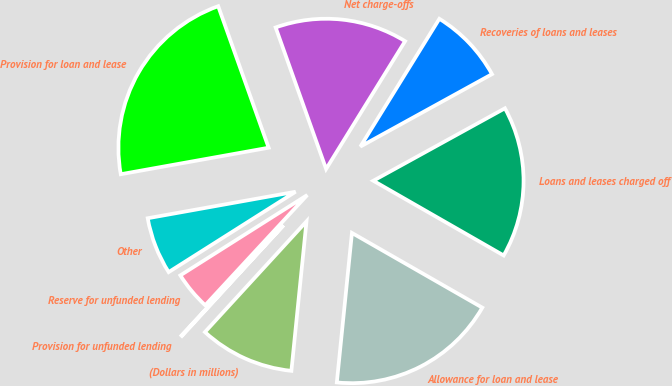<chart> <loc_0><loc_0><loc_500><loc_500><pie_chart><fcel>(Dollars in millions)<fcel>Allowance for loan and lease<fcel>Loans and leases charged off<fcel>Recoveries of loans and leases<fcel>Net charge-offs<fcel>Provision for loan and lease<fcel>Other<fcel>Reserve for unfunded lending<fcel>Provision for unfunded lending<nl><fcel>10.21%<fcel>18.32%<fcel>16.29%<fcel>8.18%<fcel>14.26%<fcel>22.37%<fcel>6.16%<fcel>4.13%<fcel>0.07%<nl></chart> 